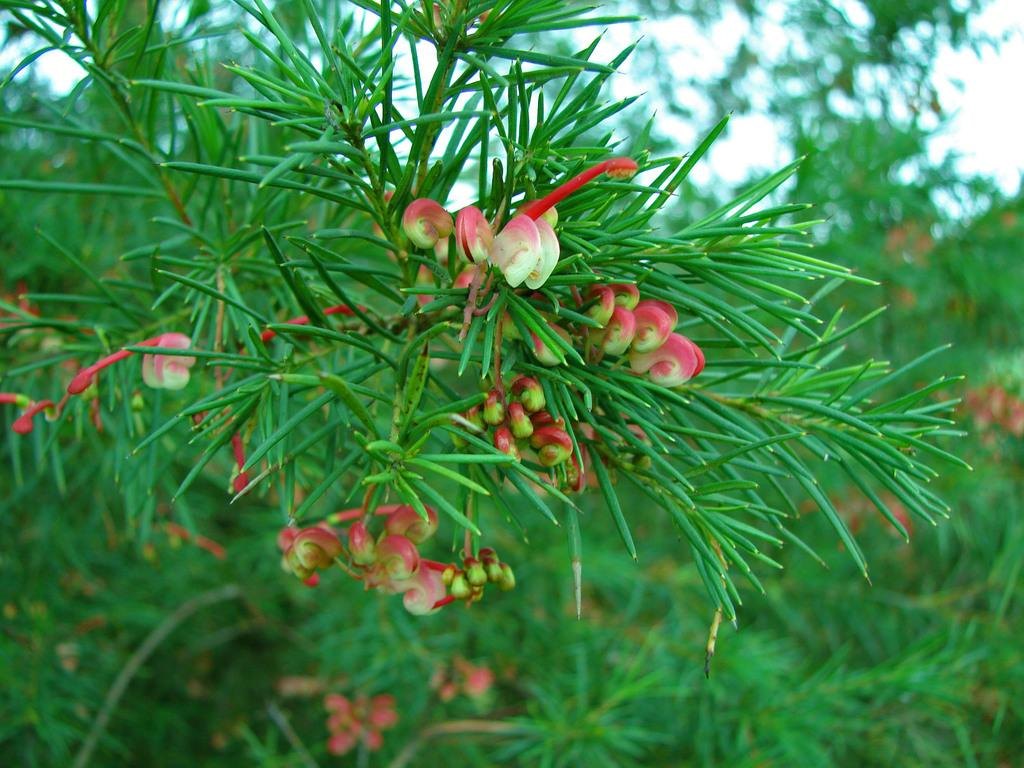What type of plants can be seen in the image? There are plants with flowers in the image. What stage of growth are the plants in? The plants have buds. Can you describe the background of the image? There are more plants visible in the background, and the sky is partially visible. What advertisement can be seen on the basketball court in the image? There is no basketball court or advertisement present in the image; it features plants with flowers and a background with more plants and the sky. 